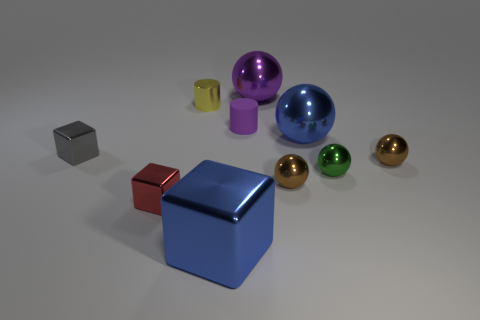Is the number of tiny green metallic things that are in front of the red block less than the number of tiny shiny cylinders that are on the right side of the purple metal thing?
Your answer should be compact. No. There is a small metal object that is in front of the small gray block and left of the small yellow metal thing; what shape is it?
Provide a short and direct response. Cube. The blue sphere that is made of the same material as the tiny gray block is what size?
Your response must be concise. Large. Does the shiny cylinder have the same color as the small matte cylinder that is on the left side of the big blue ball?
Provide a short and direct response. No. There is a big thing that is in front of the large purple metal ball and right of the large blue block; what material is it made of?
Make the answer very short. Metal. What size is the object that is the same color as the big metal cube?
Keep it short and to the point. Large. Does the large thing that is behind the small yellow cylinder have the same shape as the large blue object that is in front of the red cube?
Your answer should be compact. No. What is the color of the other small matte thing that is the same shape as the yellow thing?
Your answer should be very brief. Purple. What is the color of the shiny cylinder that is the same size as the red object?
Keep it short and to the point. Yellow. Is the red thing made of the same material as the blue ball?
Give a very brief answer. Yes. 